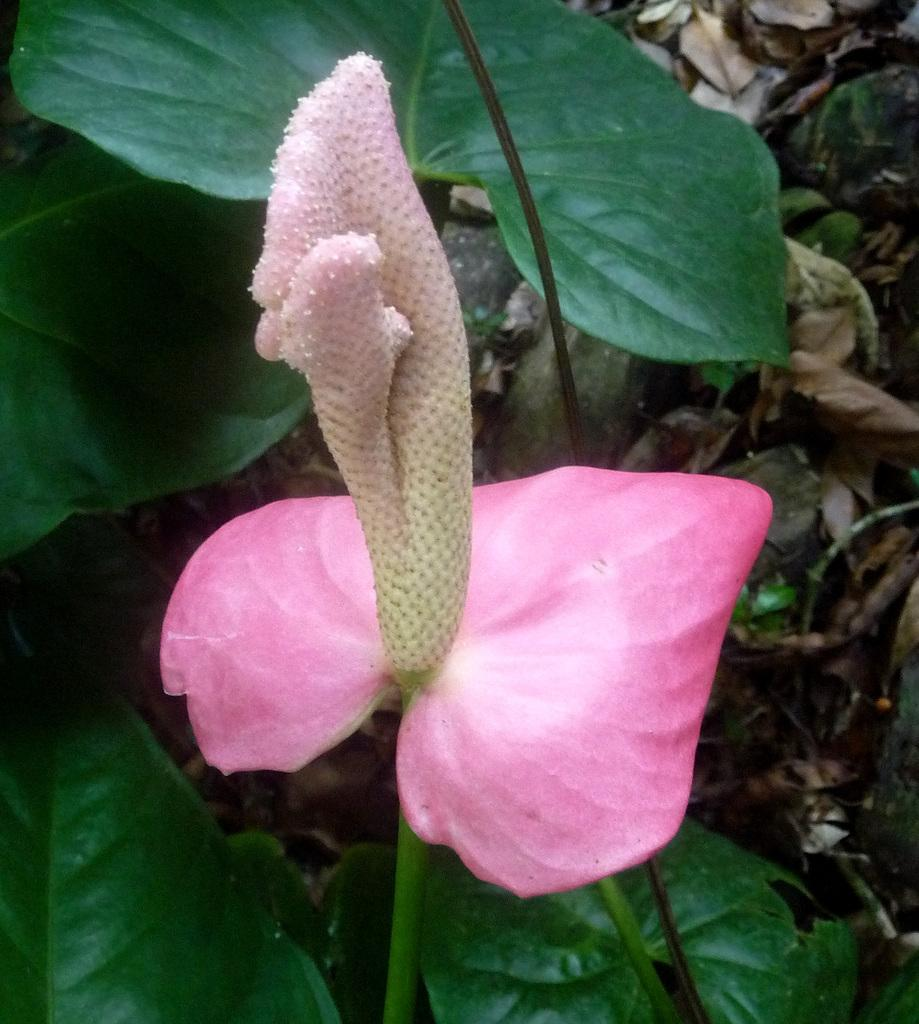What type of flower is present in the image? There is a pink flower in the image. What color are the leaves associated with the flower? There are green leaves in the image. What can be seen in the background of the image? There are dried leaves in the background of the image. What type of guide is depicted in the image? There is no guide present in the image; it features a pink flower and green leaves. What is the image hanging on in the image? The image does not depict a picture hanging on a wall or any other surface. 